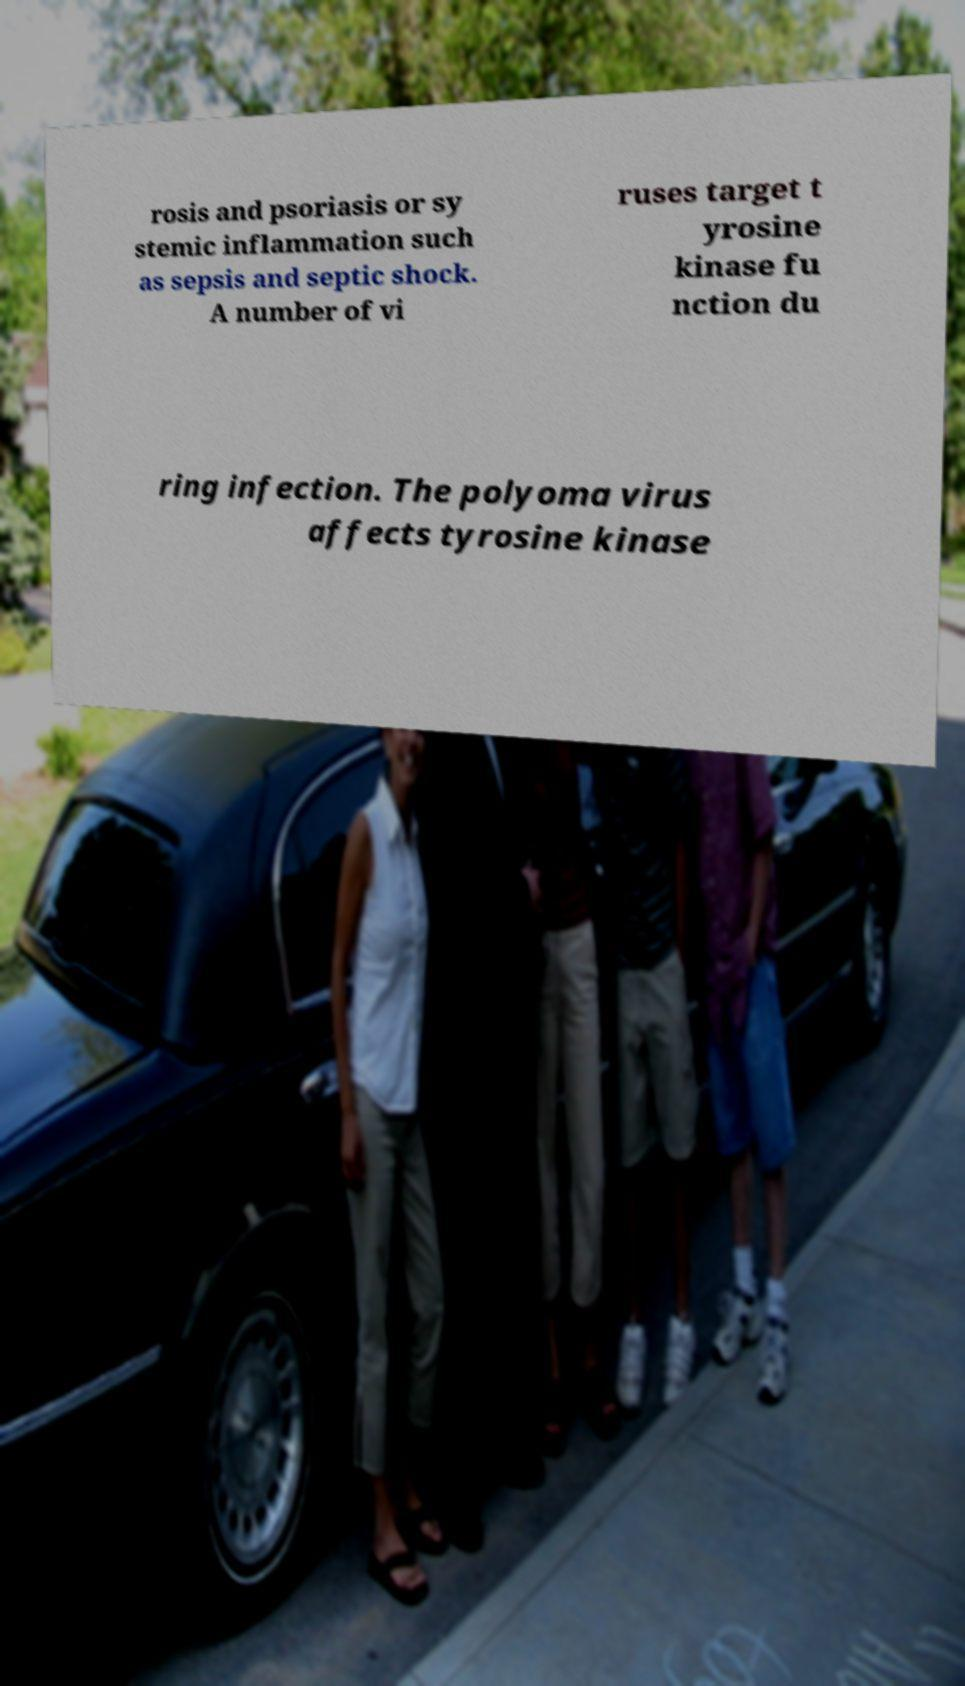Please read and relay the text visible in this image. What does it say? rosis and psoriasis or sy stemic inflammation such as sepsis and septic shock. A number of vi ruses target t yrosine kinase fu nction du ring infection. The polyoma virus affects tyrosine kinase 